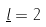<formula> <loc_0><loc_0><loc_500><loc_500>\underline { l } = 2</formula> 